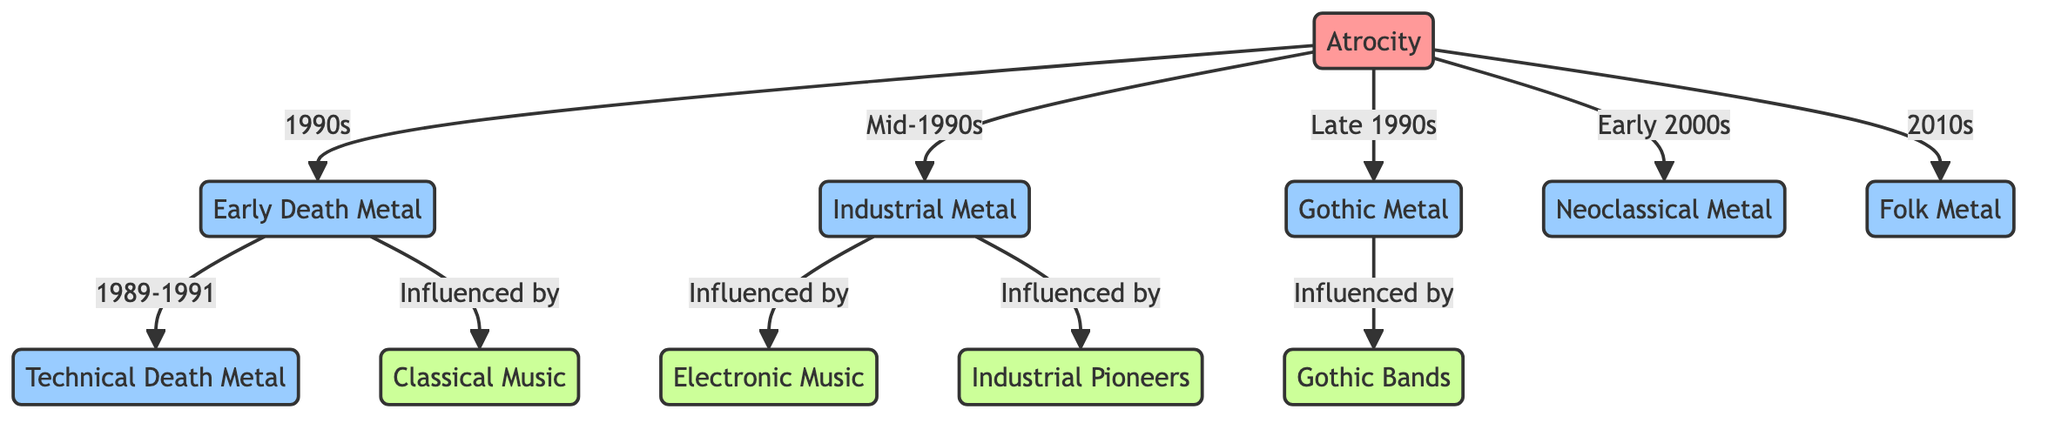What genres are directly connected to Atrocity? By following the edges directly connected to the node representing Atrocity, the genres it is connected to are Early Death Metal, Industrial Metal, Gothic Metal, Neoclassical Metal, and Folk Metal.
Answer: Early Death Metal, Industrial Metal, Gothic Metal, Neoclassical Metal, Folk Metal How many musical influences are shown in the diagram? Counting the nodes categorized as influence, we find four: Classical Music, Electronic Music, Industrial Pioneers, and Gothic Bands.
Answer: 4 What is the transition period between Early Death Metal and Technical Death Metal? The edge connecting Early Death Metal to Technical Death Metal specifies the period as 1989-1991.
Answer: 1989-1991 Which genre is influenced by Classical Music? The edge from Early Death Metal to Classical Music indicates that Early Death Metal is influenced by Classical Music.
Answer: Early Death Metal In which era did Atrocity transition to Gothic Metal? The edge from Atrocity to Gothic Metal specifies the transition occurring in the Late 1990s.
Answer: Late 1990s What influences are connected to Industrial Metal? Industrial Metal has two influences: it is connected to Electronic Music and Industrial Pioneers.
Answer: Electronic Music, Industrial Pioneers Which genre came after Technical Death Metal in the diagram? Looking at the flow, we see that the next genre connected after Technical Death Metal is Industrial Metal, as represented by the directed edge from Technical Death Metal to Industrial Metal.
Answer: Industrial Metal What is the last genre progression represented in the diagram? Following the edges, the last genre connected to Atrocity is Folk Metal in the 2010s, which indicates this is the most recent genre progression shown.
Answer: Folk Metal 